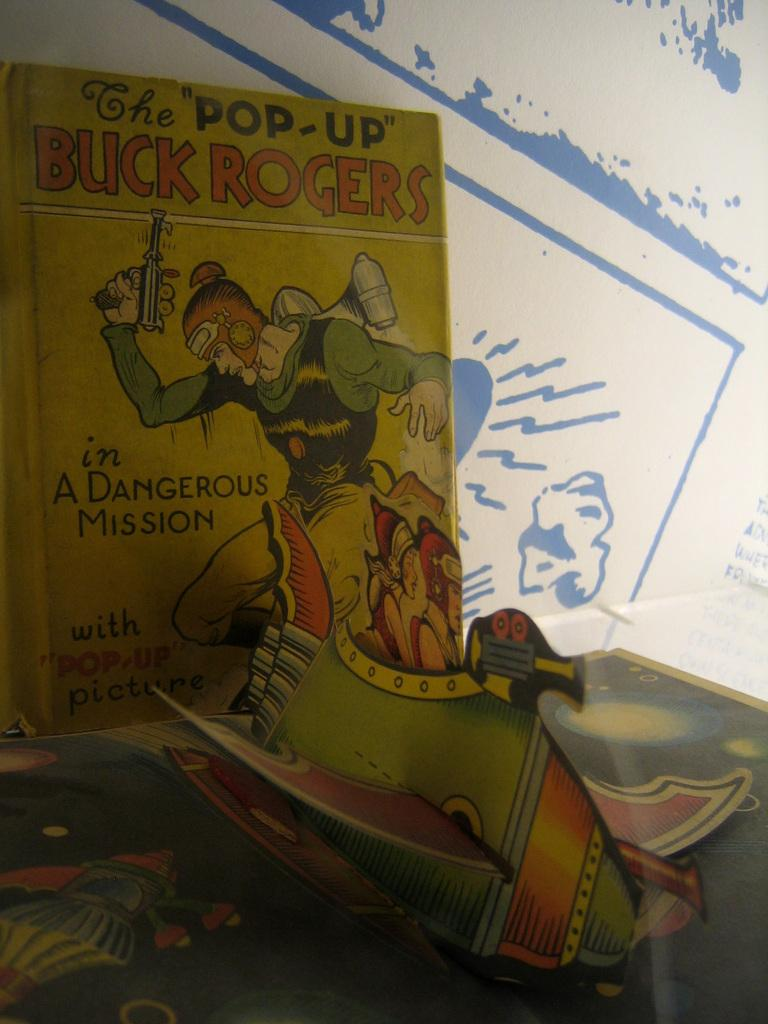<image>
Summarize the visual content of the image. A book called the Pop-Up Buck Rogers in a Dangerous Mission. 